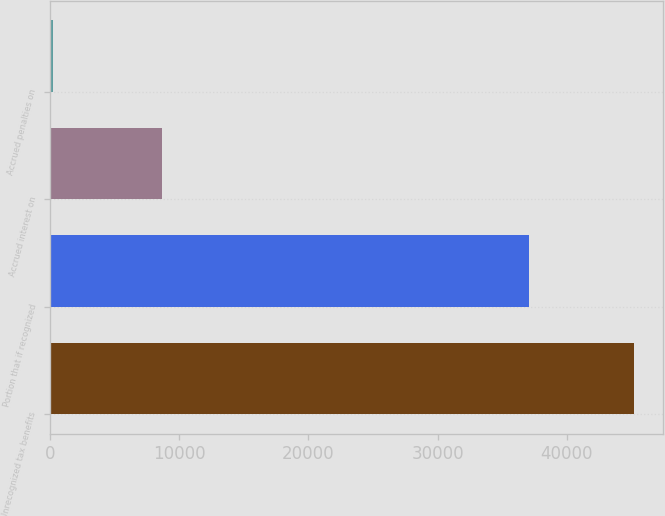<chart> <loc_0><loc_0><loc_500><loc_500><bar_chart><fcel>Unrecognized tax benefits<fcel>Portion that if recognized<fcel>Accrued interest on<fcel>Accrued penalties on<nl><fcel>45201<fcel>37054<fcel>8694<fcel>213<nl></chart> 